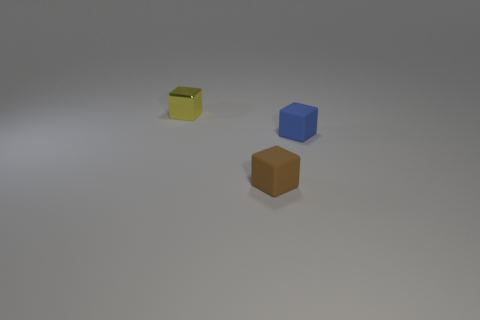How many objects are either tiny things that are right of the yellow object or yellow metallic objects?
Make the answer very short. 3. Are there any yellow metallic things that are to the right of the blue block that is behind the small matte cube in front of the tiny blue matte object?
Give a very brief answer. No. Are there fewer shiny objects in front of the blue rubber block than small yellow things that are behind the tiny brown block?
Keep it short and to the point. Yes. There is another object that is the same material as the blue thing; what color is it?
Offer a terse response. Brown. There is a rubber block that is in front of the small matte block to the right of the brown rubber object; what color is it?
Provide a short and direct response. Brown. Are there any large cubes that have the same color as the metal object?
Ensure brevity in your answer.  No. What shape is the brown matte thing that is the same size as the blue block?
Offer a very short reply. Cube. There is a small matte cube that is behind the small brown cube; how many small objects are behind it?
Your answer should be compact. 1. How many other things are there of the same material as the small brown thing?
Offer a very short reply. 1. What is the size of the blue rubber cube right of the tiny brown matte thing?
Offer a very short reply. Small. 